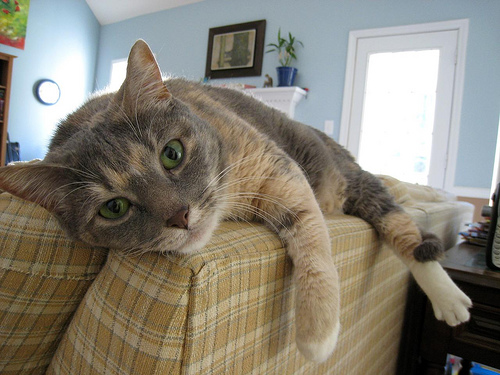What breed does this cat resemble? The cat in the image looks like it may be a domestic shorthair, which is a common breed characterized by a wide range of colorations and patterns. 